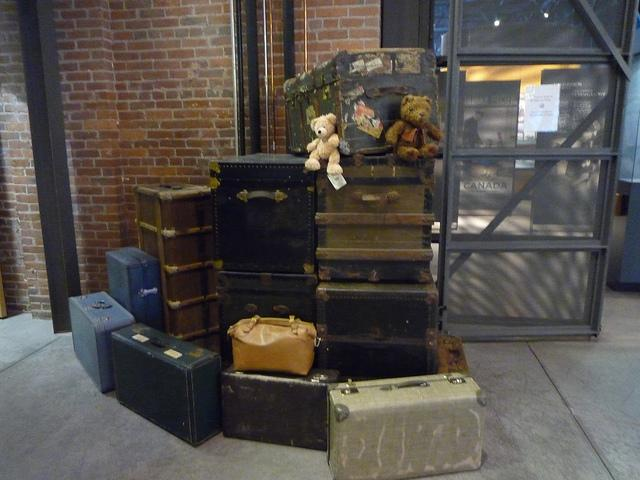What business is this display promoting? travel 